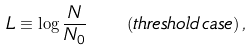<formula> <loc_0><loc_0><loc_500><loc_500>L \equiv \log \frac { N } { N _ { 0 } } \quad \left ( t h r e s h o l d \, c a s e \right ) ,</formula> 